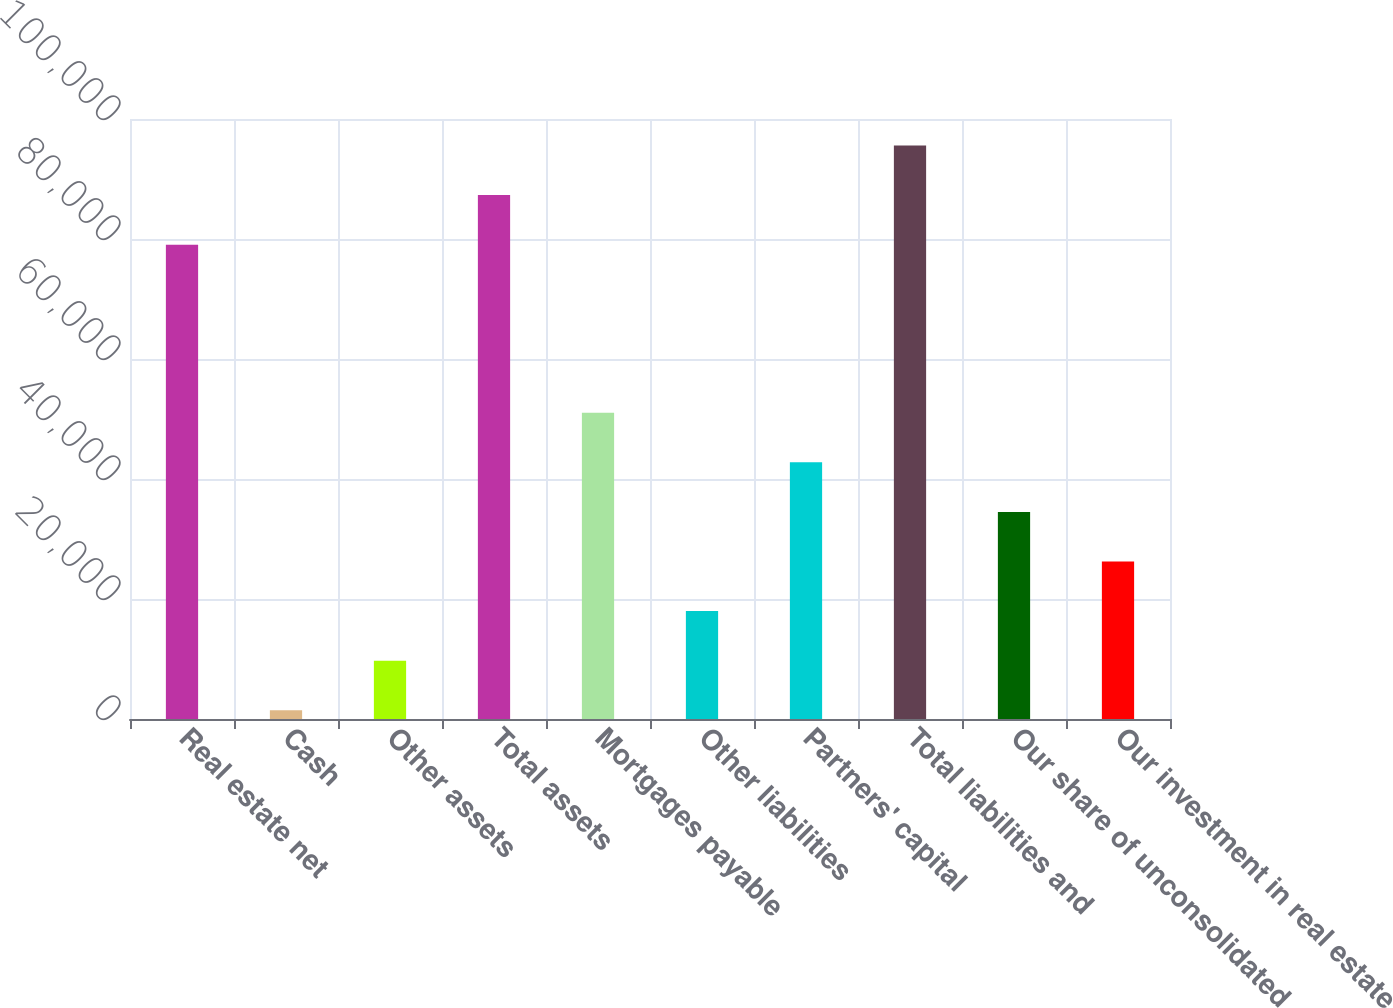Convert chart to OTSL. <chart><loc_0><loc_0><loc_500><loc_500><bar_chart><fcel>Real estate net<fcel>Cash<fcel>Other assets<fcel>Total assets<fcel>Mortgages payable<fcel>Other liabilities<fcel>Partners' capital<fcel>Total liabilities and<fcel>Our share of unconsolidated<fcel>Our investment in real estate<nl><fcel>79050<fcel>1452<fcel>9716.9<fcel>87314.9<fcel>51041.4<fcel>17981.8<fcel>42776.5<fcel>95579.8<fcel>34511.6<fcel>26246.7<nl></chart> 